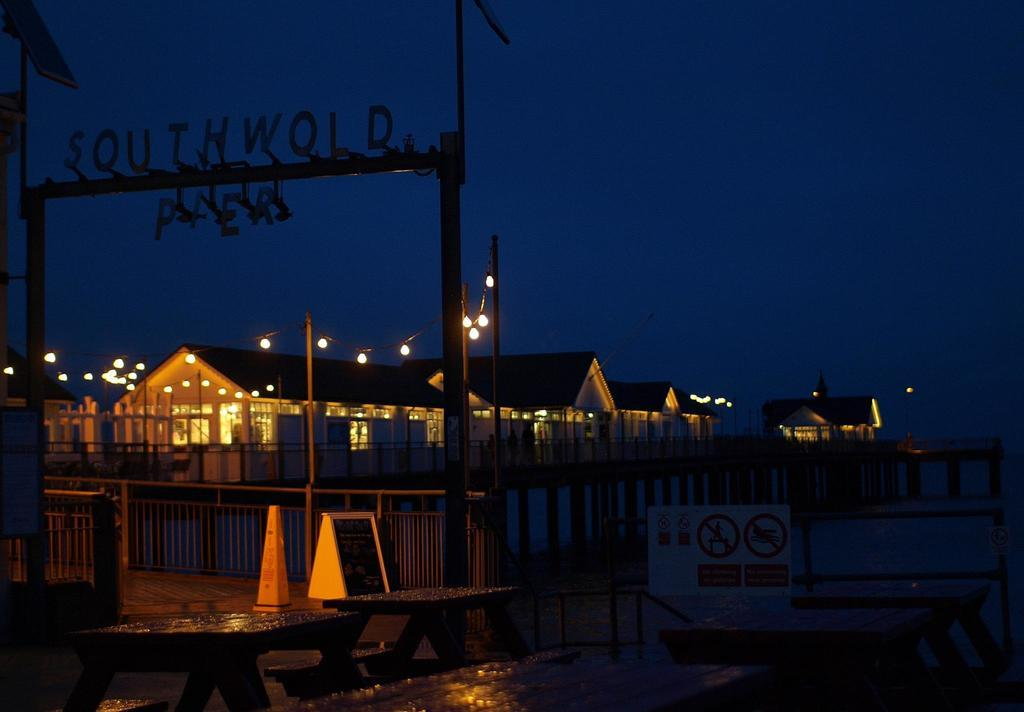What type of structures can be seen in the image? There are houses in the image. What is the purpose of the fence in the image? The fence serves as a boundary or barrier in the image. What are the wooden poles used for in the image? The wooden poles might be used for support or decoration in the image. What type of lighting is present in the image? Decorative lights are visible in the image. What objects can be found on the floor in the image? There are objects on the floor in the image, but their specific nature is not mentioned in the facts. What is the sign board on the table used for in the image? The sign board on the table might be used for displaying information or advertising in the image. What is the natural element visible in the image? Water is visible in the image. What part of the environment is visible in the image? The sky is visible in the image. Where is the crate located in the image? There is no crate present in the image. What type of paste is being used to stick the seat to the wall in the image? There is no seat or paste present in the image. 